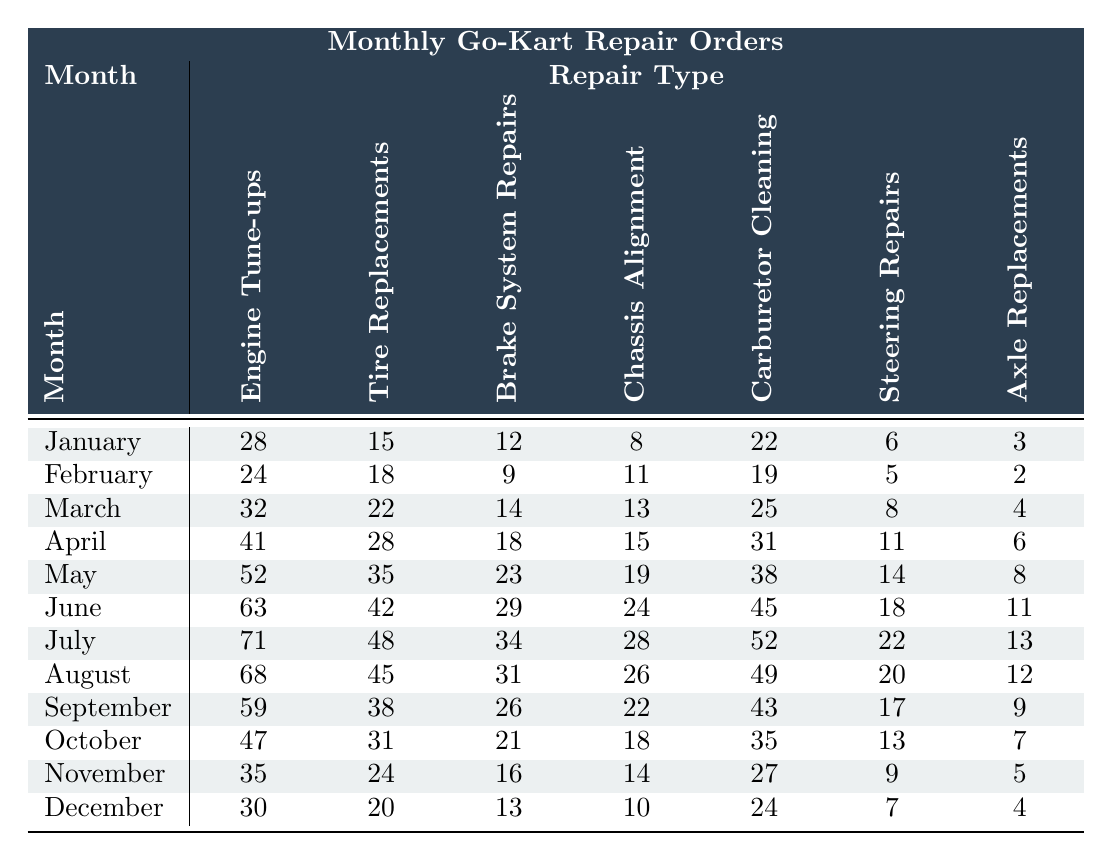What was the highest number of Engine Tune-ups recorded in a month? Looking at the table, the highest number of Engine Tune-ups is found in July with 71.
Answer: 71 Which month had the least number of Tire Replacements? By examining the table, February had the least number of Tire Replacements at 18.
Answer: 18 What is the total number of Brake System Repairs completed over the year? To find the total, we sum the monthly values: 12 + 9 + 14 + 18 + 23 + 29 + 34 + 31 + 26 + 21 + 16 + 13 =  40 + 8 + 80 =  20 +  5 + 0 =  {12 + 9 + 14 + 18 + 23 + 29 + 34 + 31 + 26 + 21 + 16 + 13} =  307.
Answer: 307 What was the average number of Chassis Alignments per month throughout the year? To calculate the average, first sum the monthly values: 8 + 11 + 13 + 15 + 19 + 24 + 28 + 26 + 22 + 18 + 14 + 10 = 285; then divide by the number of months (12): 285 / 12 = 23.75.
Answer: 23.75 Did the number of Carburetor Cleanings increase every month? A quick look through the monthly values shows that the numbers fluctuate; they increase and decrease, showing no consistent increase.
Answer: No Which repair type had the most variation in repairs throughout the year? The variation can be calculated by comparing the monthly counts for each repair type. Engine Tune-ups started at 28 and peaked at 71, while others had smaller ranges. Engine Tune-ups show the largest range of 43.
Answer: Engine Tune-ups How many more Steering Repairs were there in July compared to November? From the table, July had 22 Steering Repairs and November had 9. The difference is 22 - 9 = 13.
Answer: 13 What is the total number of Axle Replacements completed in the first half of the year? Adding the values from January to June gives us: 3 + 2 + 4 + 6 + 8 + 11 = 34.
Answer: 34 In which month did the number of Tire Replacements equal 38? A review of the table reveals that September had 38 Tire Replacements, as indicated in the monthly data.
Answer: September What is the trend for Engine Tune-ups over the months? By examining the counts, we see a steady increase in Engine Tune-ups over the months from January (28) to July (71), followed by a decline toward December (30).
Answer: Increasing then decreasing 